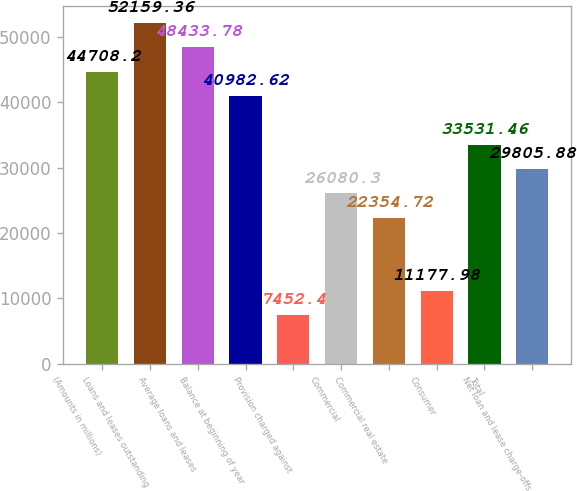Convert chart. <chart><loc_0><loc_0><loc_500><loc_500><bar_chart><fcel>(Amounts in millions)<fcel>Loans and leases outstanding<fcel>Average loans and leases<fcel>Balance at beginning of year<fcel>Provision charged against<fcel>Commercial<fcel>Commercial real estate<fcel>Consumer<fcel>Total<fcel>Net loan and lease charge-offs<nl><fcel>44708.2<fcel>52159.4<fcel>48433.8<fcel>40982.6<fcel>7452.4<fcel>26080.3<fcel>22354.7<fcel>11178<fcel>33531.5<fcel>29805.9<nl></chart> 